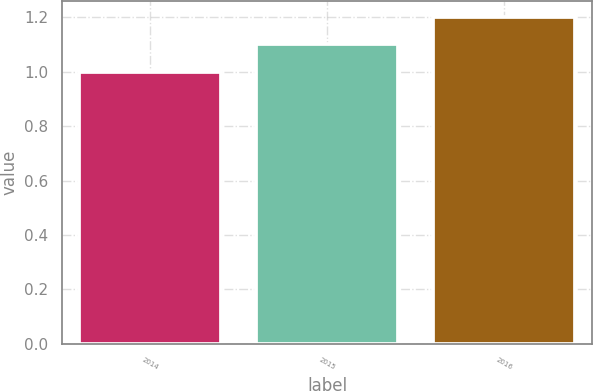<chart> <loc_0><loc_0><loc_500><loc_500><bar_chart><fcel>2014<fcel>2015<fcel>2016<nl><fcel>1<fcel>1.1<fcel>1.2<nl></chart> 